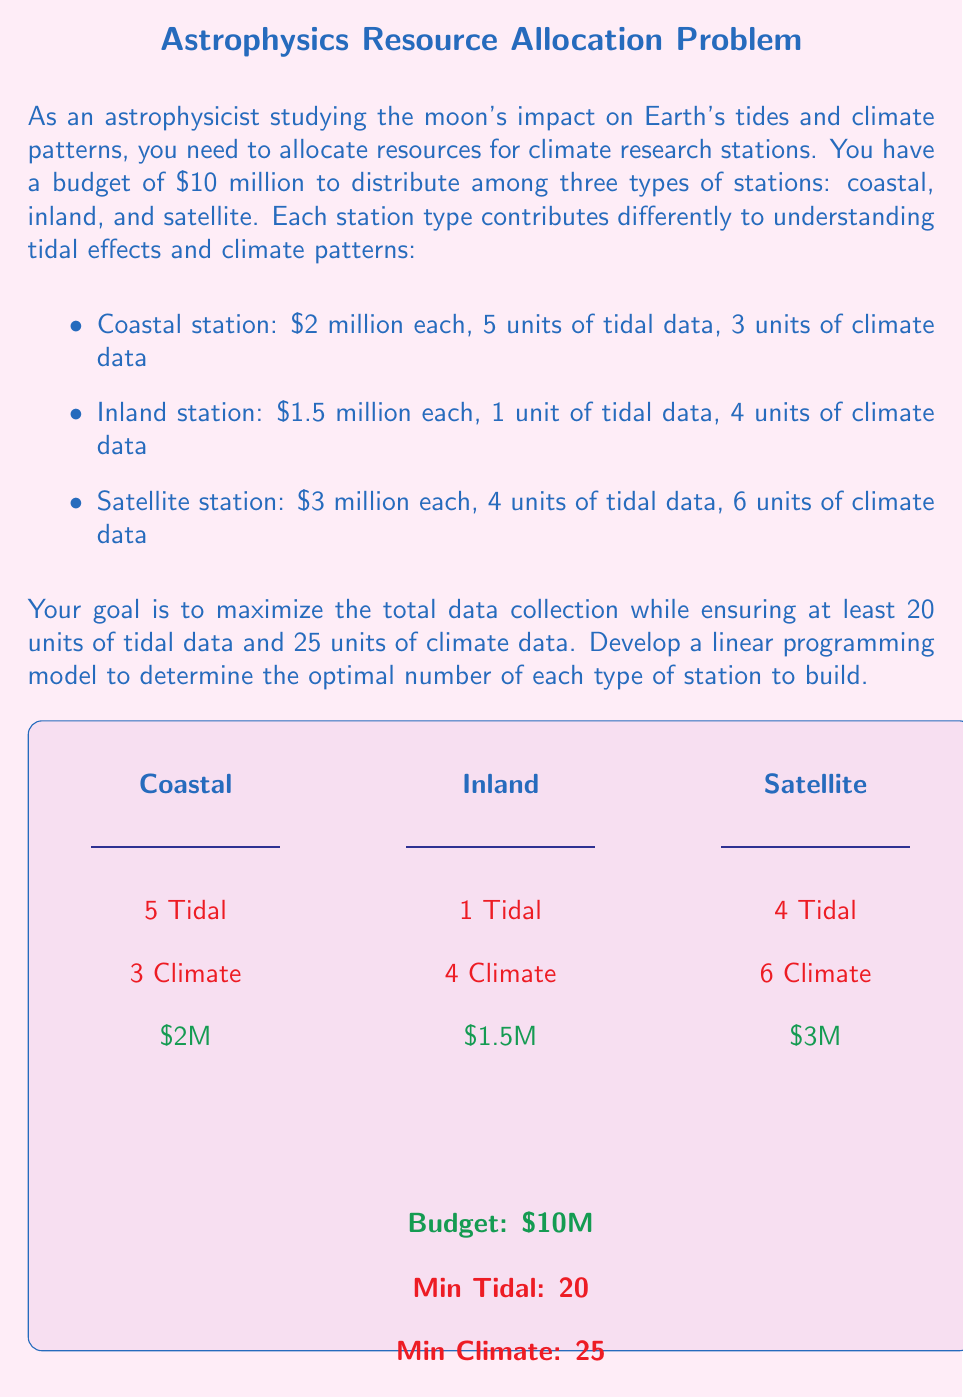Give your solution to this math problem. Let's develop the linear programming model step by step:

1. Define variables:
   Let $x$ = number of coastal stations
   Let $y$ = number of inland stations
   Let $z$ = number of satellite stations

2. Objective function:
   Maximize total data collection = $(5+3)x + (1+4)y + (4+6)z$
   Simplify: Maximize $8x + 5y + 10z$

3. Constraints:
   a) Budget constraint:
      $2x + 1.5y + 3z \leq 10$ (in millions)

   b) Tidal data constraint:
      $5x + y + 4z \geq 20$

   c) Climate data constraint:
      $3x + 4y + 6z \geq 25$

   d) Non-negativity constraints:
      $x \geq 0$, $y \geq 0$, $z \geq 0$

4. Final linear programming model:

   Maximize: $8x + 5y + 10z$

   Subject to:
   $$\begin{align*}
   2x + 1.5y + 3z &\leq 10 \\
   5x + y + 4z &\geq 20 \\
   3x + 4y + 6z &\geq 25 \\
   x, y, z &\geq 0 \\
   x, y, z &\in \mathbb{Z}
   \end{align*}$$

   Note: The last constraint ensures that the variables are integers, as we can't have fractional stations.

This model can be solved using integer linear programming techniques, such as the branch and bound method or cutting plane algorithm.
Answer: Maximize: $8x + 5y + 10z$ subject to $2x + 1.5y + 3z \leq 10$, $5x + y + 4z \geq 20$, $3x + 4y + 6z \geq 25$, $x,y,z \geq 0$ and integer 